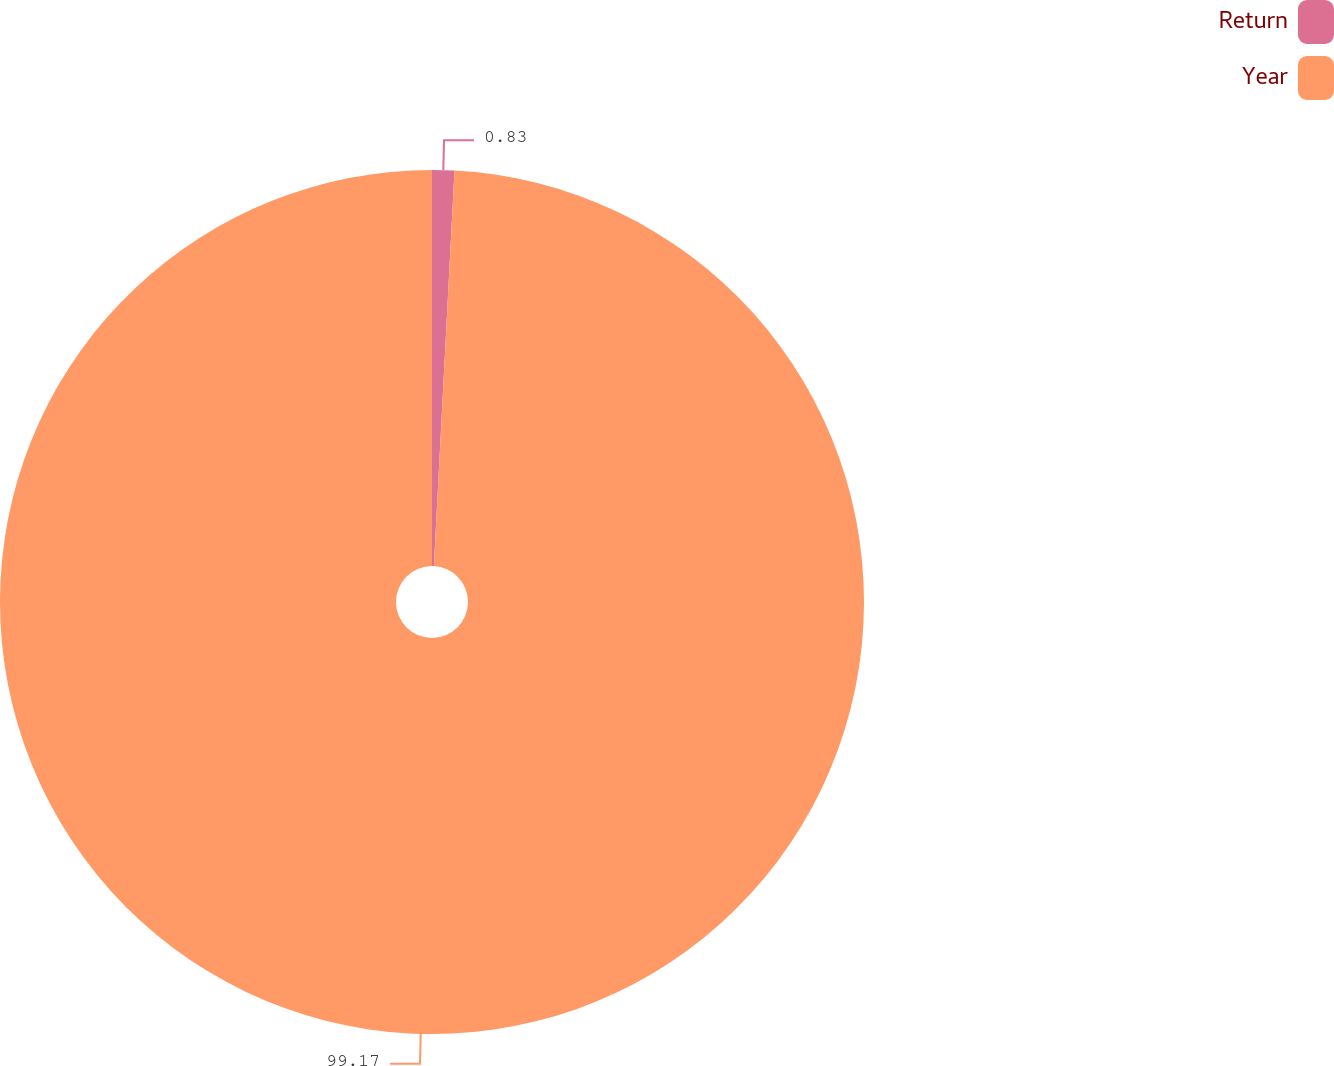Convert chart. <chart><loc_0><loc_0><loc_500><loc_500><pie_chart><fcel>Return<fcel>Year<nl><fcel>0.83%<fcel>99.17%<nl></chart> 